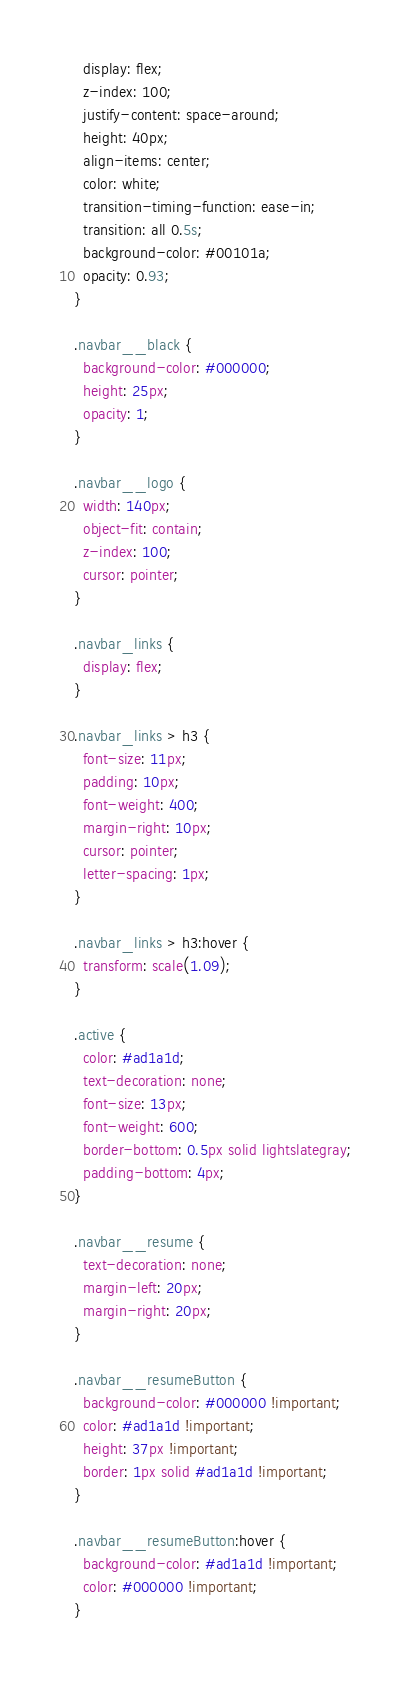Convert code to text. <code><loc_0><loc_0><loc_500><loc_500><_CSS_>  display: flex;
  z-index: 100;
  justify-content: space-around;
  height: 40px;
  align-items: center;
  color: white;
  transition-timing-function: ease-in;
  transition: all 0.5s;
  background-color: #00101a;
  opacity: 0.93;
}

.navbar__black {
  background-color: #000000;
  height: 25px;
  opacity: 1;
}

.navbar__logo {
  width: 140px;
  object-fit: contain;
  z-index: 100;
  cursor: pointer;
}

.navbar_links {
  display: flex;
}

.navbar_links > h3 {
  font-size: 11px;
  padding: 10px;
  font-weight: 400;
  margin-right: 10px;
  cursor: pointer;
  letter-spacing: 1px;
}

.navbar_links > h3:hover {
  transform: scale(1.09);
}

.active {
  color: #ad1a1d;
  text-decoration: none;
  font-size: 13px;
  font-weight: 600;
  border-bottom: 0.5px solid lightslategray;
  padding-bottom: 4px;
}

.navbar__resume {
  text-decoration: none;
  margin-left: 20px;
  margin-right: 20px;
}

.navbar__resumeButton {
  background-color: #000000 !important;
  color: #ad1a1d !important;
  height: 37px !important;
  border: 1px solid #ad1a1d !important;
}

.navbar__resumeButton:hover {
  background-color: #ad1a1d !important;
  color: #000000 !important;
}
</code> 